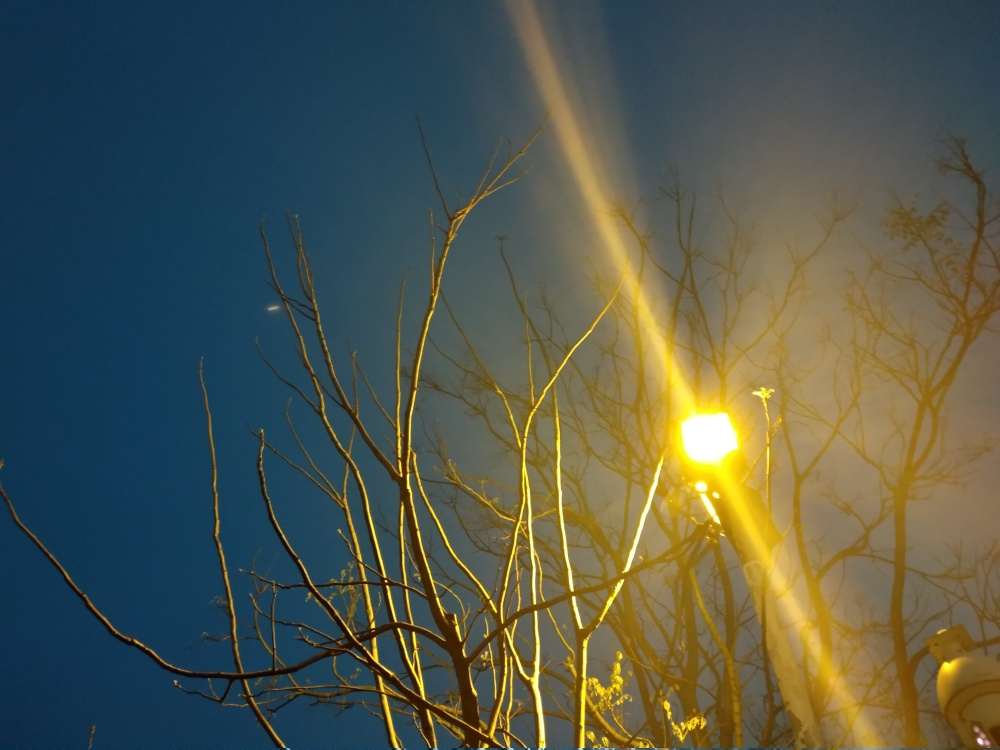What time of day does this image depict, and what mood does it evoke? The image captures the essence of twilight, with the sky transitioning from day to night. There's a quiet, contemplative mood here as the bare branches stand out against the fading light, illuminated by the street lamp's warm glow. How could this setting be used effectively in a visual narrative? This setting could provide a poignant backdrop for a story of introspection or change. The interplay of light and shadow, along with the naked branches, could symbolize both ending and a potential for new beginnings, perfect for critical turning points in a narrative. 